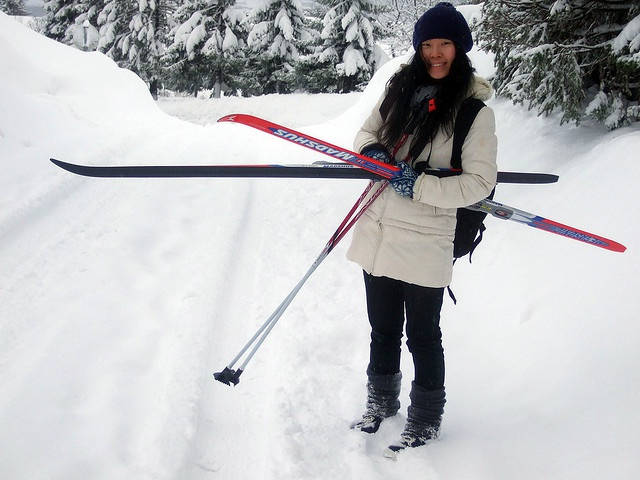Describe the objects in this image and their specific colors. I can see people in gray, black, and darkgray tones, skis in gray and black tones, and backpack in gray, black, white, and darkgray tones in this image. 